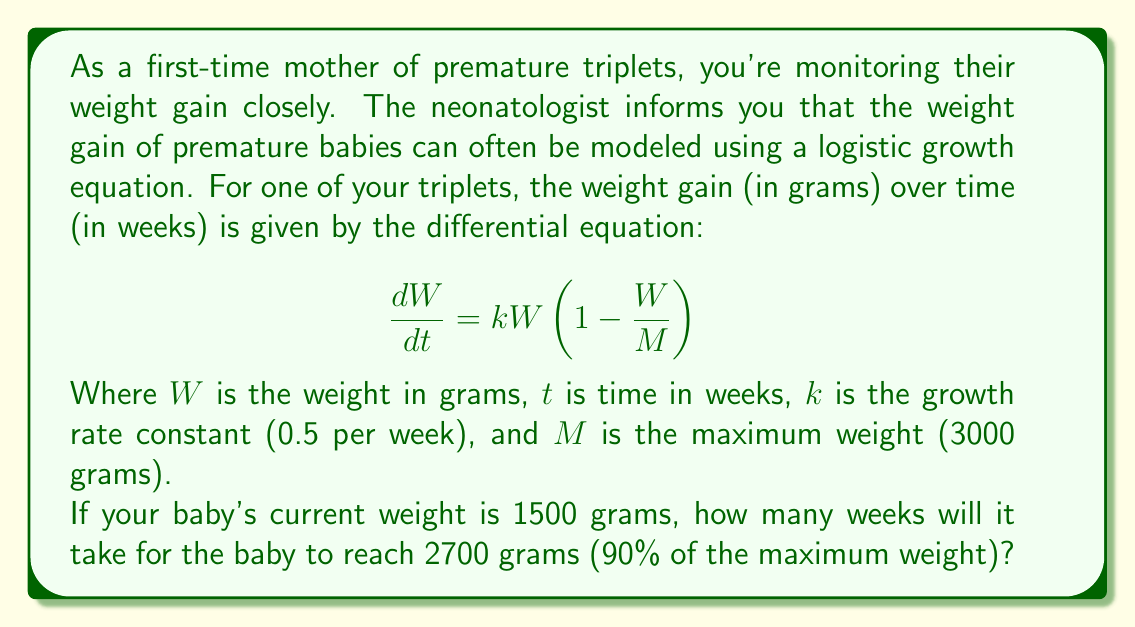Could you help me with this problem? To solve this problem, we need to integrate the logistic growth equation and solve for time. Let's follow these steps:

1) First, we separate variables and integrate:

   $$\int_{1500}^{2700} \frac{dW}{W(1-\frac{W}{3000})} = \int_0^t 0.5 dt$$

2) The left side can be integrated using partial fractions:

   $$\left[ -\ln|1-\frac{W}{3000}| - \ln|W| \right]_{1500}^{2700} = 0.5t$$

3) Evaluating the left side:

   $$\left(-\ln|1-\frac{2700}{3000}| - \ln|2700|\right) - \left(-\ln|1-\frac{1500}{3000}| - \ln|1500|\right) = 0.5t$$

4) Simplify:

   $$(-\ln|0.1| - \ln|2700|) - (-\ln|0.5| - \ln|1500|) = 0.5t$$

5) Calculate:

   $$(2.3026 - 7.9010) - (0.6931 - 7.3132) = 0.5t$$

6) Simplify further:

   $$1.1217 = 0.5t$$

7) Solve for t:

   $$t = \frac{1.1217}{0.5} = 2.2434$$

Therefore, it will take approximately 2.24 weeks for the baby to reach 2700 grams.
Answer: 2.24 weeks 